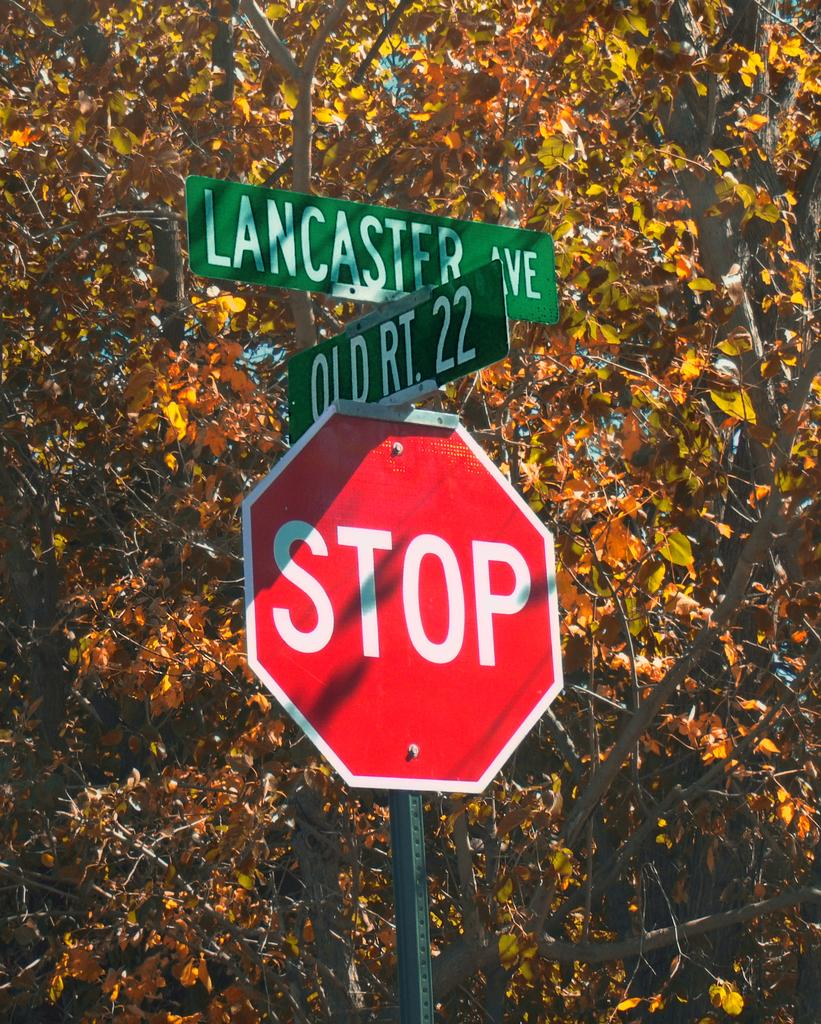<image>
Offer a succinct explanation of the picture presented. A stop sign is underneath the street signs for Lancaster Av. and Old Rt. 22. 